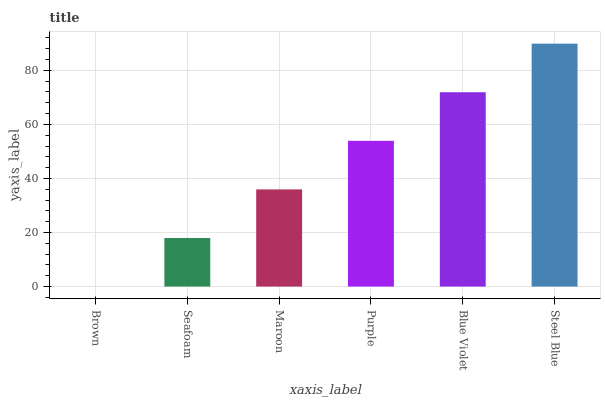Is Brown the minimum?
Answer yes or no. Yes. Is Steel Blue the maximum?
Answer yes or no. Yes. Is Seafoam the minimum?
Answer yes or no. No. Is Seafoam the maximum?
Answer yes or no. No. Is Seafoam greater than Brown?
Answer yes or no. Yes. Is Brown less than Seafoam?
Answer yes or no. Yes. Is Brown greater than Seafoam?
Answer yes or no. No. Is Seafoam less than Brown?
Answer yes or no. No. Is Purple the high median?
Answer yes or no. Yes. Is Maroon the low median?
Answer yes or no. Yes. Is Steel Blue the high median?
Answer yes or no. No. Is Steel Blue the low median?
Answer yes or no. No. 